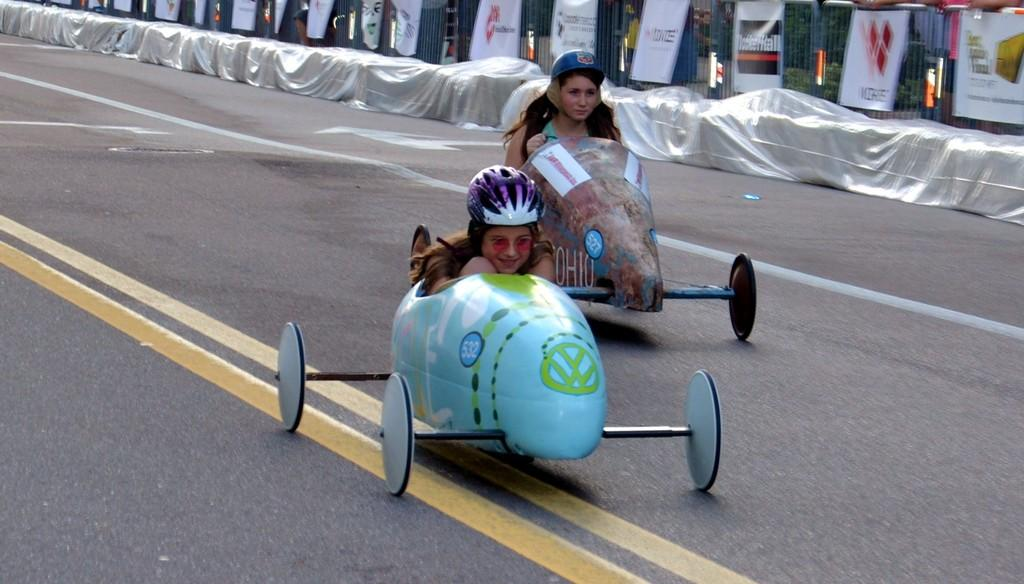How many women are in the image? There are two women in the image. What are the women wearing on their heads? The women are wearing helmets. What are the women sitting in? The women are sitting in vehicles. What is the vehicles doing in the image? The vehicles are moving on a road. What can be seen in the background of the image? There are covers and banners in the background of the image. What type of building can be seen in the image? There is no building present in the image; it features two women sitting in vehicles on a road. What is the source of the shock experienced by the women in the image? There is no shock experienced by the women in the image; they are simply sitting in vehicles that are moving on a road. 